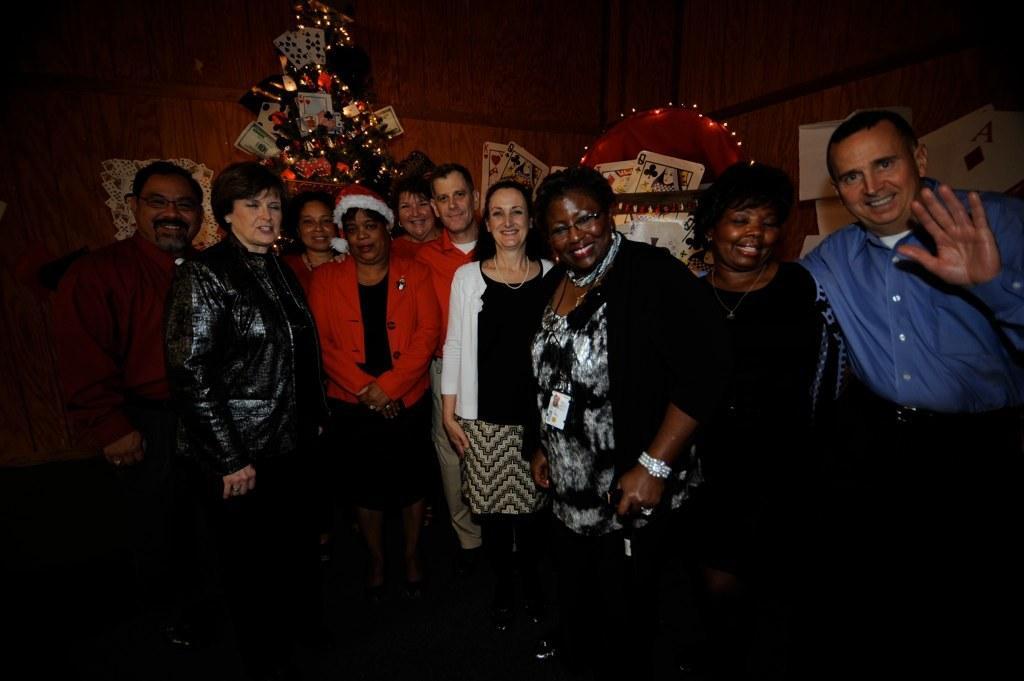In one or two sentences, can you explain what this image depicts? There are group of people standing here. All are having a smile on their faces. There are some women and men in this group. Behind them there is a christmas tree decorated with lights and some large cards on the wall. We can observe a wall in the background. 